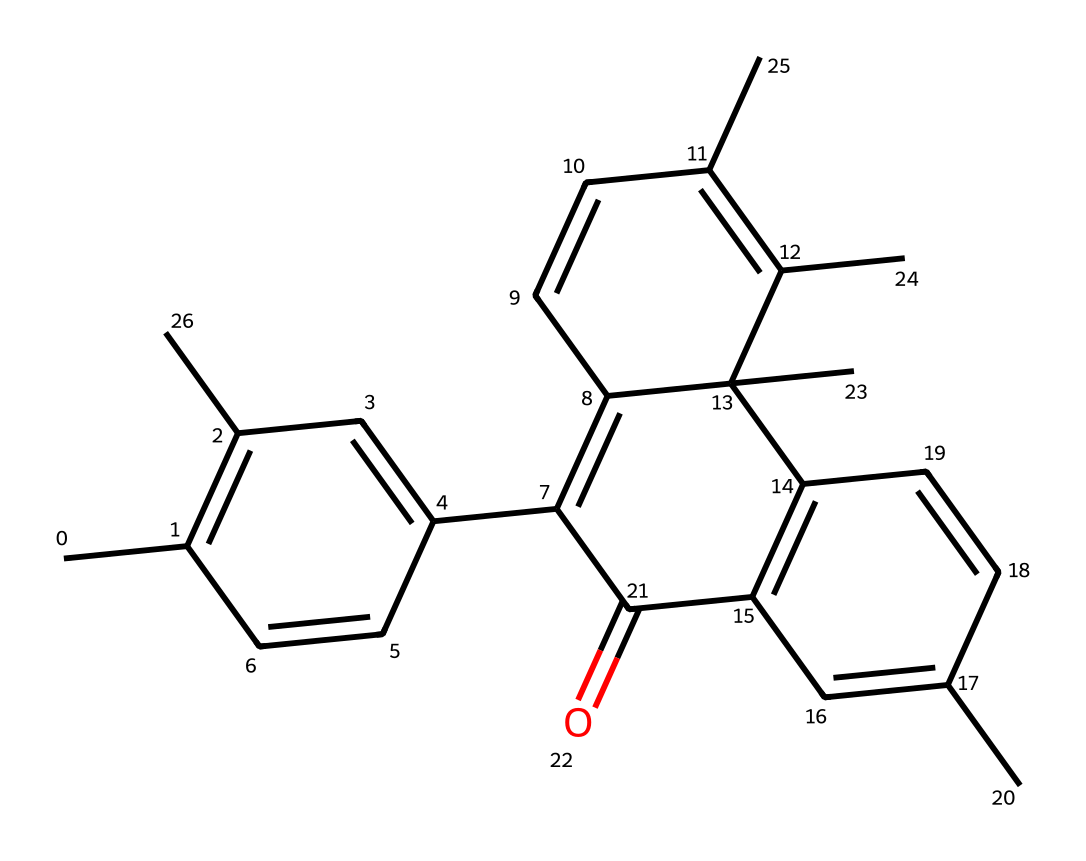What is the main type of compound represented by this chemical? The structure indicates that it is a complex organic molecule, possibly a photochromic compound, which is commonly found in lenses that change color when exposed to light.
Answer: photochromic How many carbon atoms are present in this chemical? By analyzing the SMILES representation, we can count the 'C' symbols, which indicate carbon atoms. There are 27 carbon atoms in total.
Answer: 27 What functional group is indicated by the 'O' in the structure? The presence of 'O' typically suggests the presence of a carbonyl group or ether linkage; in this context, it indicates a ketone functional group based on its placement in the molecule.
Answer: ketone What effect does this chemical primarily have when exposed to UV light? This compound undergoes a structural change when exposed to UV light, leading to an increase in pigmentation, which darkens the lens to block harmful rays.
Answer: darkening Does this compound contain any rings in its structure? By examining the structure, we can identify various ring structures formed by carbon atoms; the presence of multiple cycles confirms that it has rings.
Answer: yes What is the potential application of this chemical in everyday products? Given its photochromic properties, this chemical is primarily used in eyeglass lenses that adjust to sunlight, enhancing UV protection for the eyes.
Answer: eyeglass lenses 